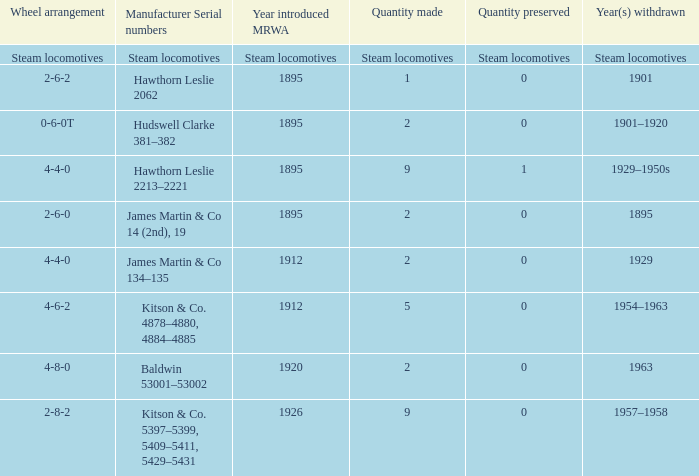What is the manufacturing serial number for the 1963 discontinued year? Baldwin 53001–53002. 